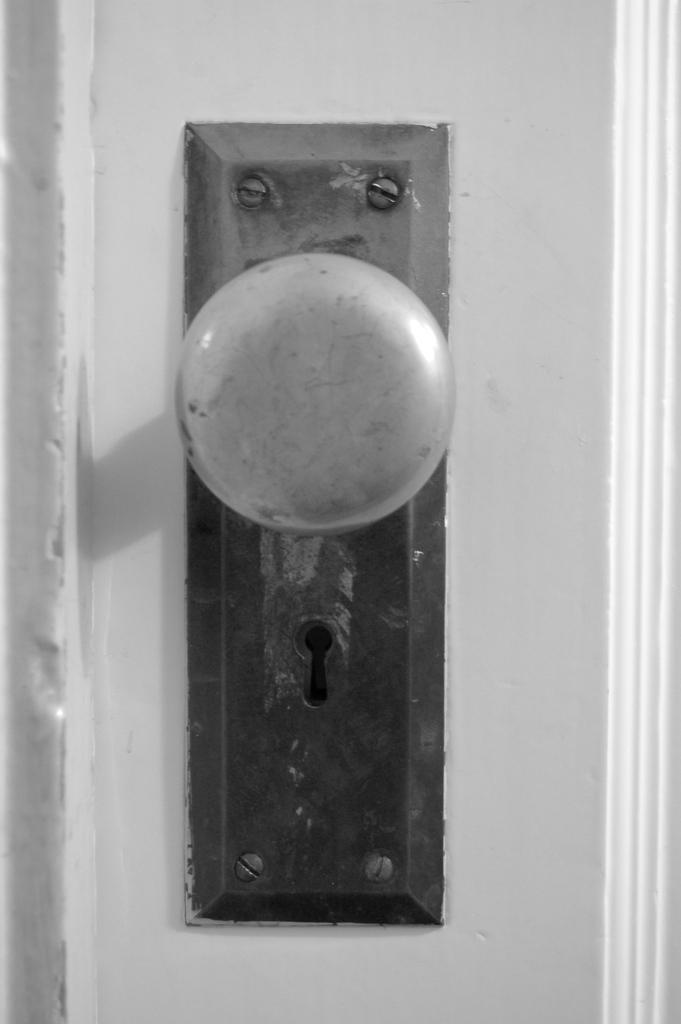Could you give a brief overview of what you see in this image? In this picture we can observe a door lock handle fixed to the door. There is a keyhole. We can observe a white color door here. 